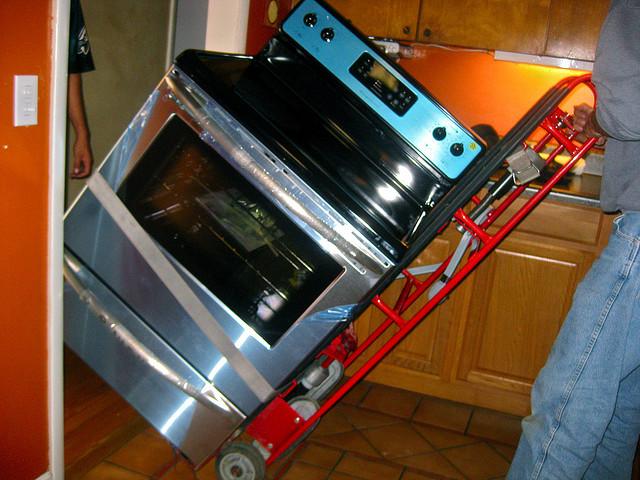Are they taking the stove in or out of the kitchen?
Be succinct. In. Is this dangerous?
Write a very short answer. Yes. Is this broken?
Write a very short answer. Yes. Is this a new stove?
Give a very brief answer. Yes. 